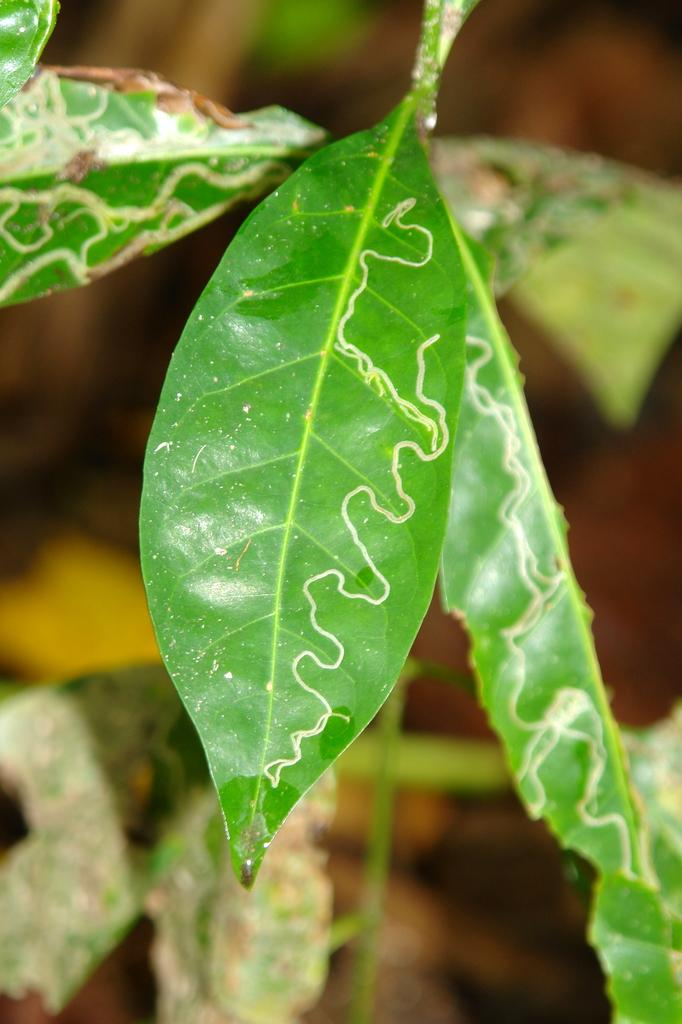What type of natural elements can be seen in the image? There are leaves in the image. What color are the lines in the image? The lines in the image are brown. Can you compare the leaves in the image to the leaves of a friend's favorite tree? There is no information about a friend's favorite tree in the image, so it cannot be compared. 